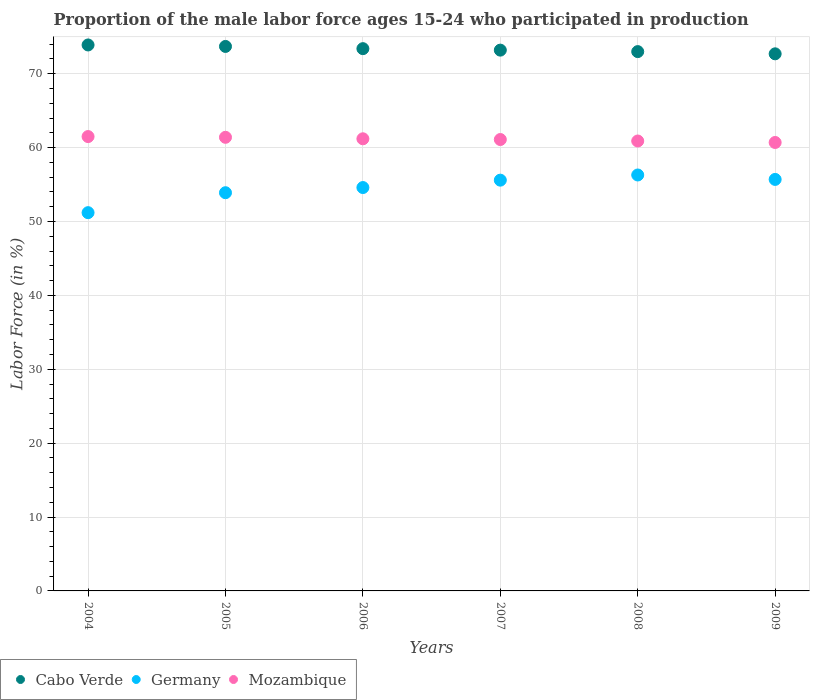How many different coloured dotlines are there?
Your response must be concise. 3. What is the proportion of the male labor force who participated in production in Mozambique in 2008?
Your response must be concise. 60.9. Across all years, what is the maximum proportion of the male labor force who participated in production in Cabo Verde?
Your answer should be very brief. 73.9. Across all years, what is the minimum proportion of the male labor force who participated in production in Cabo Verde?
Provide a succinct answer. 72.7. In which year was the proportion of the male labor force who participated in production in Germany minimum?
Offer a very short reply. 2004. What is the total proportion of the male labor force who participated in production in Germany in the graph?
Offer a terse response. 327.3. What is the difference between the proportion of the male labor force who participated in production in Germany in 2005 and that in 2009?
Your answer should be very brief. -1.8. What is the difference between the proportion of the male labor force who participated in production in Mozambique in 2008 and the proportion of the male labor force who participated in production in Cabo Verde in 2009?
Offer a terse response. -11.8. What is the average proportion of the male labor force who participated in production in Cabo Verde per year?
Your answer should be compact. 73.32. In how many years, is the proportion of the male labor force who participated in production in Mozambique greater than 62 %?
Give a very brief answer. 0. What is the ratio of the proportion of the male labor force who participated in production in Mozambique in 2007 to that in 2008?
Make the answer very short. 1. Is the difference between the proportion of the male labor force who participated in production in Mozambique in 2004 and 2005 greater than the difference between the proportion of the male labor force who participated in production in Germany in 2004 and 2005?
Offer a terse response. Yes. What is the difference between the highest and the second highest proportion of the male labor force who participated in production in Germany?
Offer a terse response. 0.6. What is the difference between the highest and the lowest proportion of the male labor force who participated in production in Cabo Verde?
Your answer should be very brief. 1.2. Is the sum of the proportion of the male labor force who participated in production in Germany in 2004 and 2005 greater than the maximum proportion of the male labor force who participated in production in Cabo Verde across all years?
Your answer should be compact. Yes. Is the proportion of the male labor force who participated in production in Mozambique strictly greater than the proportion of the male labor force who participated in production in Germany over the years?
Offer a terse response. Yes. How many dotlines are there?
Keep it short and to the point. 3. Does the graph contain grids?
Your answer should be very brief. Yes. How many legend labels are there?
Provide a succinct answer. 3. How are the legend labels stacked?
Ensure brevity in your answer.  Horizontal. What is the title of the graph?
Provide a short and direct response. Proportion of the male labor force ages 15-24 who participated in production. Does "American Samoa" appear as one of the legend labels in the graph?
Make the answer very short. No. What is the label or title of the Y-axis?
Provide a succinct answer. Labor Force (in %). What is the Labor Force (in %) in Cabo Verde in 2004?
Ensure brevity in your answer.  73.9. What is the Labor Force (in %) in Germany in 2004?
Give a very brief answer. 51.2. What is the Labor Force (in %) in Mozambique in 2004?
Give a very brief answer. 61.5. What is the Labor Force (in %) in Cabo Verde in 2005?
Your answer should be compact. 73.7. What is the Labor Force (in %) in Germany in 2005?
Provide a succinct answer. 53.9. What is the Labor Force (in %) in Mozambique in 2005?
Give a very brief answer. 61.4. What is the Labor Force (in %) in Cabo Verde in 2006?
Your answer should be compact. 73.4. What is the Labor Force (in %) of Germany in 2006?
Provide a short and direct response. 54.6. What is the Labor Force (in %) in Mozambique in 2006?
Keep it short and to the point. 61.2. What is the Labor Force (in %) in Cabo Verde in 2007?
Make the answer very short. 73.2. What is the Labor Force (in %) of Germany in 2007?
Provide a short and direct response. 55.6. What is the Labor Force (in %) of Mozambique in 2007?
Your answer should be very brief. 61.1. What is the Labor Force (in %) in Germany in 2008?
Give a very brief answer. 56.3. What is the Labor Force (in %) in Mozambique in 2008?
Your response must be concise. 60.9. What is the Labor Force (in %) of Cabo Verde in 2009?
Your response must be concise. 72.7. What is the Labor Force (in %) in Germany in 2009?
Offer a very short reply. 55.7. What is the Labor Force (in %) in Mozambique in 2009?
Ensure brevity in your answer.  60.7. Across all years, what is the maximum Labor Force (in %) of Cabo Verde?
Provide a short and direct response. 73.9. Across all years, what is the maximum Labor Force (in %) of Germany?
Keep it short and to the point. 56.3. Across all years, what is the maximum Labor Force (in %) in Mozambique?
Offer a very short reply. 61.5. Across all years, what is the minimum Labor Force (in %) of Cabo Verde?
Provide a succinct answer. 72.7. Across all years, what is the minimum Labor Force (in %) of Germany?
Offer a terse response. 51.2. Across all years, what is the minimum Labor Force (in %) of Mozambique?
Provide a short and direct response. 60.7. What is the total Labor Force (in %) of Cabo Verde in the graph?
Offer a terse response. 439.9. What is the total Labor Force (in %) of Germany in the graph?
Give a very brief answer. 327.3. What is the total Labor Force (in %) in Mozambique in the graph?
Offer a terse response. 366.8. What is the difference between the Labor Force (in %) in Mozambique in 2004 and that in 2005?
Make the answer very short. 0.1. What is the difference between the Labor Force (in %) in Germany in 2004 and that in 2006?
Make the answer very short. -3.4. What is the difference between the Labor Force (in %) of Mozambique in 2004 and that in 2006?
Provide a succinct answer. 0.3. What is the difference between the Labor Force (in %) in Cabo Verde in 2004 and that in 2008?
Provide a short and direct response. 0.9. What is the difference between the Labor Force (in %) of Germany in 2004 and that in 2008?
Offer a very short reply. -5.1. What is the difference between the Labor Force (in %) in Mozambique in 2004 and that in 2008?
Provide a short and direct response. 0.6. What is the difference between the Labor Force (in %) in Cabo Verde in 2004 and that in 2009?
Provide a short and direct response. 1.2. What is the difference between the Labor Force (in %) in Germany in 2004 and that in 2009?
Give a very brief answer. -4.5. What is the difference between the Labor Force (in %) of Mozambique in 2004 and that in 2009?
Your response must be concise. 0.8. What is the difference between the Labor Force (in %) of Germany in 2005 and that in 2006?
Provide a succinct answer. -0.7. What is the difference between the Labor Force (in %) of Mozambique in 2005 and that in 2006?
Your response must be concise. 0.2. What is the difference between the Labor Force (in %) in Cabo Verde in 2005 and that in 2007?
Keep it short and to the point. 0.5. What is the difference between the Labor Force (in %) of Germany in 2005 and that in 2007?
Give a very brief answer. -1.7. What is the difference between the Labor Force (in %) of Mozambique in 2005 and that in 2007?
Your answer should be compact. 0.3. What is the difference between the Labor Force (in %) in Cabo Verde in 2005 and that in 2009?
Make the answer very short. 1. What is the difference between the Labor Force (in %) of Mozambique in 2005 and that in 2009?
Your response must be concise. 0.7. What is the difference between the Labor Force (in %) of Mozambique in 2006 and that in 2007?
Offer a very short reply. 0.1. What is the difference between the Labor Force (in %) of Cabo Verde in 2006 and that in 2008?
Your response must be concise. 0.4. What is the difference between the Labor Force (in %) in Germany in 2006 and that in 2008?
Offer a terse response. -1.7. What is the difference between the Labor Force (in %) of Mozambique in 2006 and that in 2008?
Offer a very short reply. 0.3. What is the difference between the Labor Force (in %) in Cabo Verde in 2006 and that in 2009?
Your response must be concise. 0.7. What is the difference between the Labor Force (in %) in Germany in 2006 and that in 2009?
Provide a short and direct response. -1.1. What is the difference between the Labor Force (in %) of Cabo Verde in 2007 and that in 2008?
Your answer should be compact. 0.2. What is the difference between the Labor Force (in %) in Germany in 2007 and that in 2008?
Your answer should be very brief. -0.7. What is the difference between the Labor Force (in %) in Cabo Verde in 2004 and the Labor Force (in %) in Germany in 2005?
Your answer should be compact. 20. What is the difference between the Labor Force (in %) in Cabo Verde in 2004 and the Labor Force (in %) in Germany in 2006?
Your response must be concise. 19.3. What is the difference between the Labor Force (in %) of Cabo Verde in 2004 and the Labor Force (in %) of Mozambique in 2007?
Your response must be concise. 12.8. What is the difference between the Labor Force (in %) of Germany in 2004 and the Labor Force (in %) of Mozambique in 2007?
Offer a very short reply. -9.9. What is the difference between the Labor Force (in %) in Germany in 2004 and the Labor Force (in %) in Mozambique in 2008?
Provide a short and direct response. -9.7. What is the difference between the Labor Force (in %) of Cabo Verde in 2004 and the Labor Force (in %) of Mozambique in 2009?
Provide a succinct answer. 13.2. What is the difference between the Labor Force (in %) in Cabo Verde in 2005 and the Labor Force (in %) in Germany in 2006?
Give a very brief answer. 19.1. What is the difference between the Labor Force (in %) in Cabo Verde in 2005 and the Labor Force (in %) in Mozambique in 2006?
Make the answer very short. 12.5. What is the difference between the Labor Force (in %) of Cabo Verde in 2005 and the Labor Force (in %) of Germany in 2007?
Give a very brief answer. 18.1. What is the difference between the Labor Force (in %) of Cabo Verde in 2005 and the Labor Force (in %) of Mozambique in 2007?
Your response must be concise. 12.6. What is the difference between the Labor Force (in %) of Germany in 2005 and the Labor Force (in %) of Mozambique in 2007?
Your response must be concise. -7.2. What is the difference between the Labor Force (in %) of Cabo Verde in 2005 and the Labor Force (in %) of Germany in 2008?
Keep it short and to the point. 17.4. What is the difference between the Labor Force (in %) of Cabo Verde in 2005 and the Labor Force (in %) of Germany in 2009?
Your response must be concise. 18. What is the difference between the Labor Force (in %) in Germany in 2005 and the Labor Force (in %) in Mozambique in 2009?
Make the answer very short. -6.8. What is the difference between the Labor Force (in %) in Cabo Verde in 2006 and the Labor Force (in %) in Germany in 2007?
Provide a succinct answer. 17.8. What is the difference between the Labor Force (in %) of Cabo Verde in 2006 and the Labor Force (in %) of Mozambique in 2008?
Give a very brief answer. 12.5. What is the difference between the Labor Force (in %) in Germany in 2006 and the Labor Force (in %) in Mozambique in 2009?
Provide a short and direct response. -6.1. What is the difference between the Labor Force (in %) in Germany in 2007 and the Labor Force (in %) in Mozambique in 2008?
Offer a very short reply. -5.3. What is the difference between the Labor Force (in %) of Cabo Verde in 2007 and the Labor Force (in %) of Germany in 2009?
Provide a succinct answer. 17.5. What is the difference between the Labor Force (in %) of Cabo Verde in 2007 and the Labor Force (in %) of Mozambique in 2009?
Make the answer very short. 12.5. What is the difference between the Labor Force (in %) in Germany in 2007 and the Labor Force (in %) in Mozambique in 2009?
Offer a terse response. -5.1. What is the difference between the Labor Force (in %) of Cabo Verde in 2008 and the Labor Force (in %) of Germany in 2009?
Your answer should be compact. 17.3. What is the difference between the Labor Force (in %) in Cabo Verde in 2008 and the Labor Force (in %) in Mozambique in 2009?
Offer a very short reply. 12.3. What is the average Labor Force (in %) in Cabo Verde per year?
Provide a succinct answer. 73.32. What is the average Labor Force (in %) in Germany per year?
Your answer should be compact. 54.55. What is the average Labor Force (in %) of Mozambique per year?
Make the answer very short. 61.13. In the year 2004, what is the difference between the Labor Force (in %) of Cabo Verde and Labor Force (in %) of Germany?
Provide a succinct answer. 22.7. In the year 2004, what is the difference between the Labor Force (in %) of Cabo Verde and Labor Force (in %) of Mozambique?
Offer a very short reply. 12.4. In the year 2004, what is the difference between the Labor Force (in %) of Germany and Labor Force (in %) of Mozambique?
Your answer should be compact. -10.3. In the year 2005, what is the difference between the Labor Force (in %) in Cabo Verde and Labor Force (in %) in Germany?
Keep it short and to the point. 19.8. In the year 2005, what is the difference between the Labor Force (in %) of Germany and Labor Force (in %) of Mozambique?
Make the answer very short. -7.5. In the year 2006, what is the difference between the Labor Force (in %) in Cabo Verde and Labor Force (in %) in Germany?
Give a very brief answer. 18.8. In the year 2006, what is the difference between the Labor Force (in %) in Cabo Verde and Labor Force (in %) in Mozambique?
Provide a succinct answer. 12.2. In the year 2006, what is the difference between the Labor Force (in %) of Germany and Labor Force (in %) of Mozambique?
Ensure brevity in your answer.  -6.6. In the year 2007, what is the difference between the Labor Force (in %) in Cabo Verde and Labor Force (in %) in Germany?
Offer a terse response. 17.6. In the year 2007, what is the difference between the Labor Force (in %) in Germany and Labor Force (in %) in Mozambique?
Offer a very short reply. -5.5. In the year 2008, what is the difference between the Labor Force (in %) in Germany and Labor Force (in %) in Mozambique?
Provide a short and direct response. -4.6. In the year 2009, what is the difference between the Labor Force (in %) of Germany and Labor Force (in %) of Mozambique?
Provide a succinct answer. -5. What is the ratio of the Labor Force (in %) in Cabo Verde in 2004 to that in 2005?
Offer a very short reply. 1. What is the ratio of the Labor Force (in %) of Germany in 2004 to that in 2005?
Make the answer very short. 0.95. What is the ratio of the Labor Force (in %) of Cabo Verde in 2004 to that in 2006?
Your response must be concise. 1.01. What is the ratio of the Labor Force (in %) in Germany in 2004 to that in 2006?
Provide a short and direct response. 0.94. What is the ratio of the Labor Force (in %) in Mozambique in 2004 to that in 2006?
Provide a succinct answer. 1. What is the ratio of the Labor Force (in %) of Cabo Verde in 2004 to that in 2007?
Provide a succinct answer. 1.01. What is the ratio of the Labor Force (in %) of Germany in 2004 to that in 2007?
Ensure brevity in your answer.  0.92. What is the ratio of the Labor Force (in %) of Mozambique in 2004 to that in 2007?
Keep it short and to the point. 1.01. What is the ratio of the Labor Force (in %) in Cabo Verde in 2004 to that in 2008?
Provide a short and direct response. 1.01. What is the ratio of the Labor Force (in %) in Germany in 2004 to that in 2008?
Your response must be concise. 0.91. What is the ratio of the Labor Force (in %) of Mozambique in 2004 to that in 2008?
Give a very brief answer. 1.01. What is the ratio of the Labor Force (in %) of Cabo Verde in 2004 to that in 2009?
Make the answer very short. 1.02. What is the ratio of the Labor Force (in %) of Germany in 2004 to that in 2009?
Your answer should be compact. 0.92. What is the ratio of the Labor Force (in %) in Mozambique in 2004 to that in 2009?
Your answer should be compact. 1.01. What is the ratio of the Labor Force (in %) in Cabo Verde in 2005 to that in 2006?
Keep it short and to the point. 1. What is the ratio of the Labor Force (in %) of Germany in 2005 to that in 2006?
Offer a terse response. 0.99. What is the ratio of the Labor Force (in %) of Mozambique in 2005 to that in 2006?
Your response must be concise. 1. What is the ratio of the Labor Force (in %) of Cabo Verde in 2005 to that in 2007?
Keep it short and to the point. 1.01. What is the ratio of the Labor Force (in %) in Germany in 2005 to that in 2007?
Provide a succinct answer. 0.97. What is the ratio of the Labor Force (in %) of Cabo Verde in 2005 to that in 2008?
Make the answer very short. 1.01. What is the ratio of the Labor Force (in %) in Germany in 2005 to that in 2008?
Your response must be concise. 0.96. What is the ratio of the Labor Force (in %) of Mozambique in 2005 to that in 2008?
Ensure brevity in your answer.  1.01. What is the ratio of the Labor Force (in %) in Cabo Verde in 2005 to that in 2009?
Your answer should be very brief. 1.01. What is the ratio of the Labor Force (in %) of Germany in 2005 to that in 2009?
Provide a short and direct response. 0.97. What is the ratio of the Labor Force (in %) in Mozambique in 2005 to that in 2009?
Keep it short and to the point. 1.01. What is the ratio of the Labor Force (in %) of Cabo Verde in 2006 to that in 2007?
Your response must be concise. 1. What is the ratio of the Labor Force (in %) in Mozambique in 2006 to that in 2007?
Ensure brevity in your answer.  1. What is the ratio of the Labor Force (in %) in Cabo Verde in 2006 to that in 2008?
Your response must be concise. 1.01. What is the ratio of the Labor Force (in %) in Germany in 2006 to that in 2008?
Provide a succinct answer. 0.97. What is the ratio of the Labor Force (in %) in Mozambique in 2006 to that in 2008?
Make the answer very short. 1. What is the ratio of the Labor Force (in %) of Cabo Verde in 2006 to that in 2009?
Offer a very short reply. 1.01. What is the ratio of the Labor Force (in %) in Germany in 2006 to that in 2009?
Provide a succinct answer. 0.98. What is the ratio of the Labor Force (in %) in Mozambique in 2006 to that in 2009?
Keep it short and to the point. 1.01. What is the ratio of the Labor Force (in %) in Germany in 2007 to that in 2008?
Ensure brevity in your answer.  0.99. What is the ratio of the Labor Force (in %) of Mozambique in 2007 to that in 2009?
Your answer should be compact. 1.01. What is the ratio of the Labor Force (in %) of Germany in 2008 to that in 2009?
Your response must be concise. 1.01. What is the ratio of the Labor Force (in %) in Mozambique in 2008 to that in 2009?
Keep it short and to the point. 1. What is the difference between the highest and the second highest Labor Force (in %) of Germany?
Give a very brief answer. 0.6. What is the difference between the highest and the lowest Labor Force (in %) of Mozambique?
Offer a terse response. 0.8. 